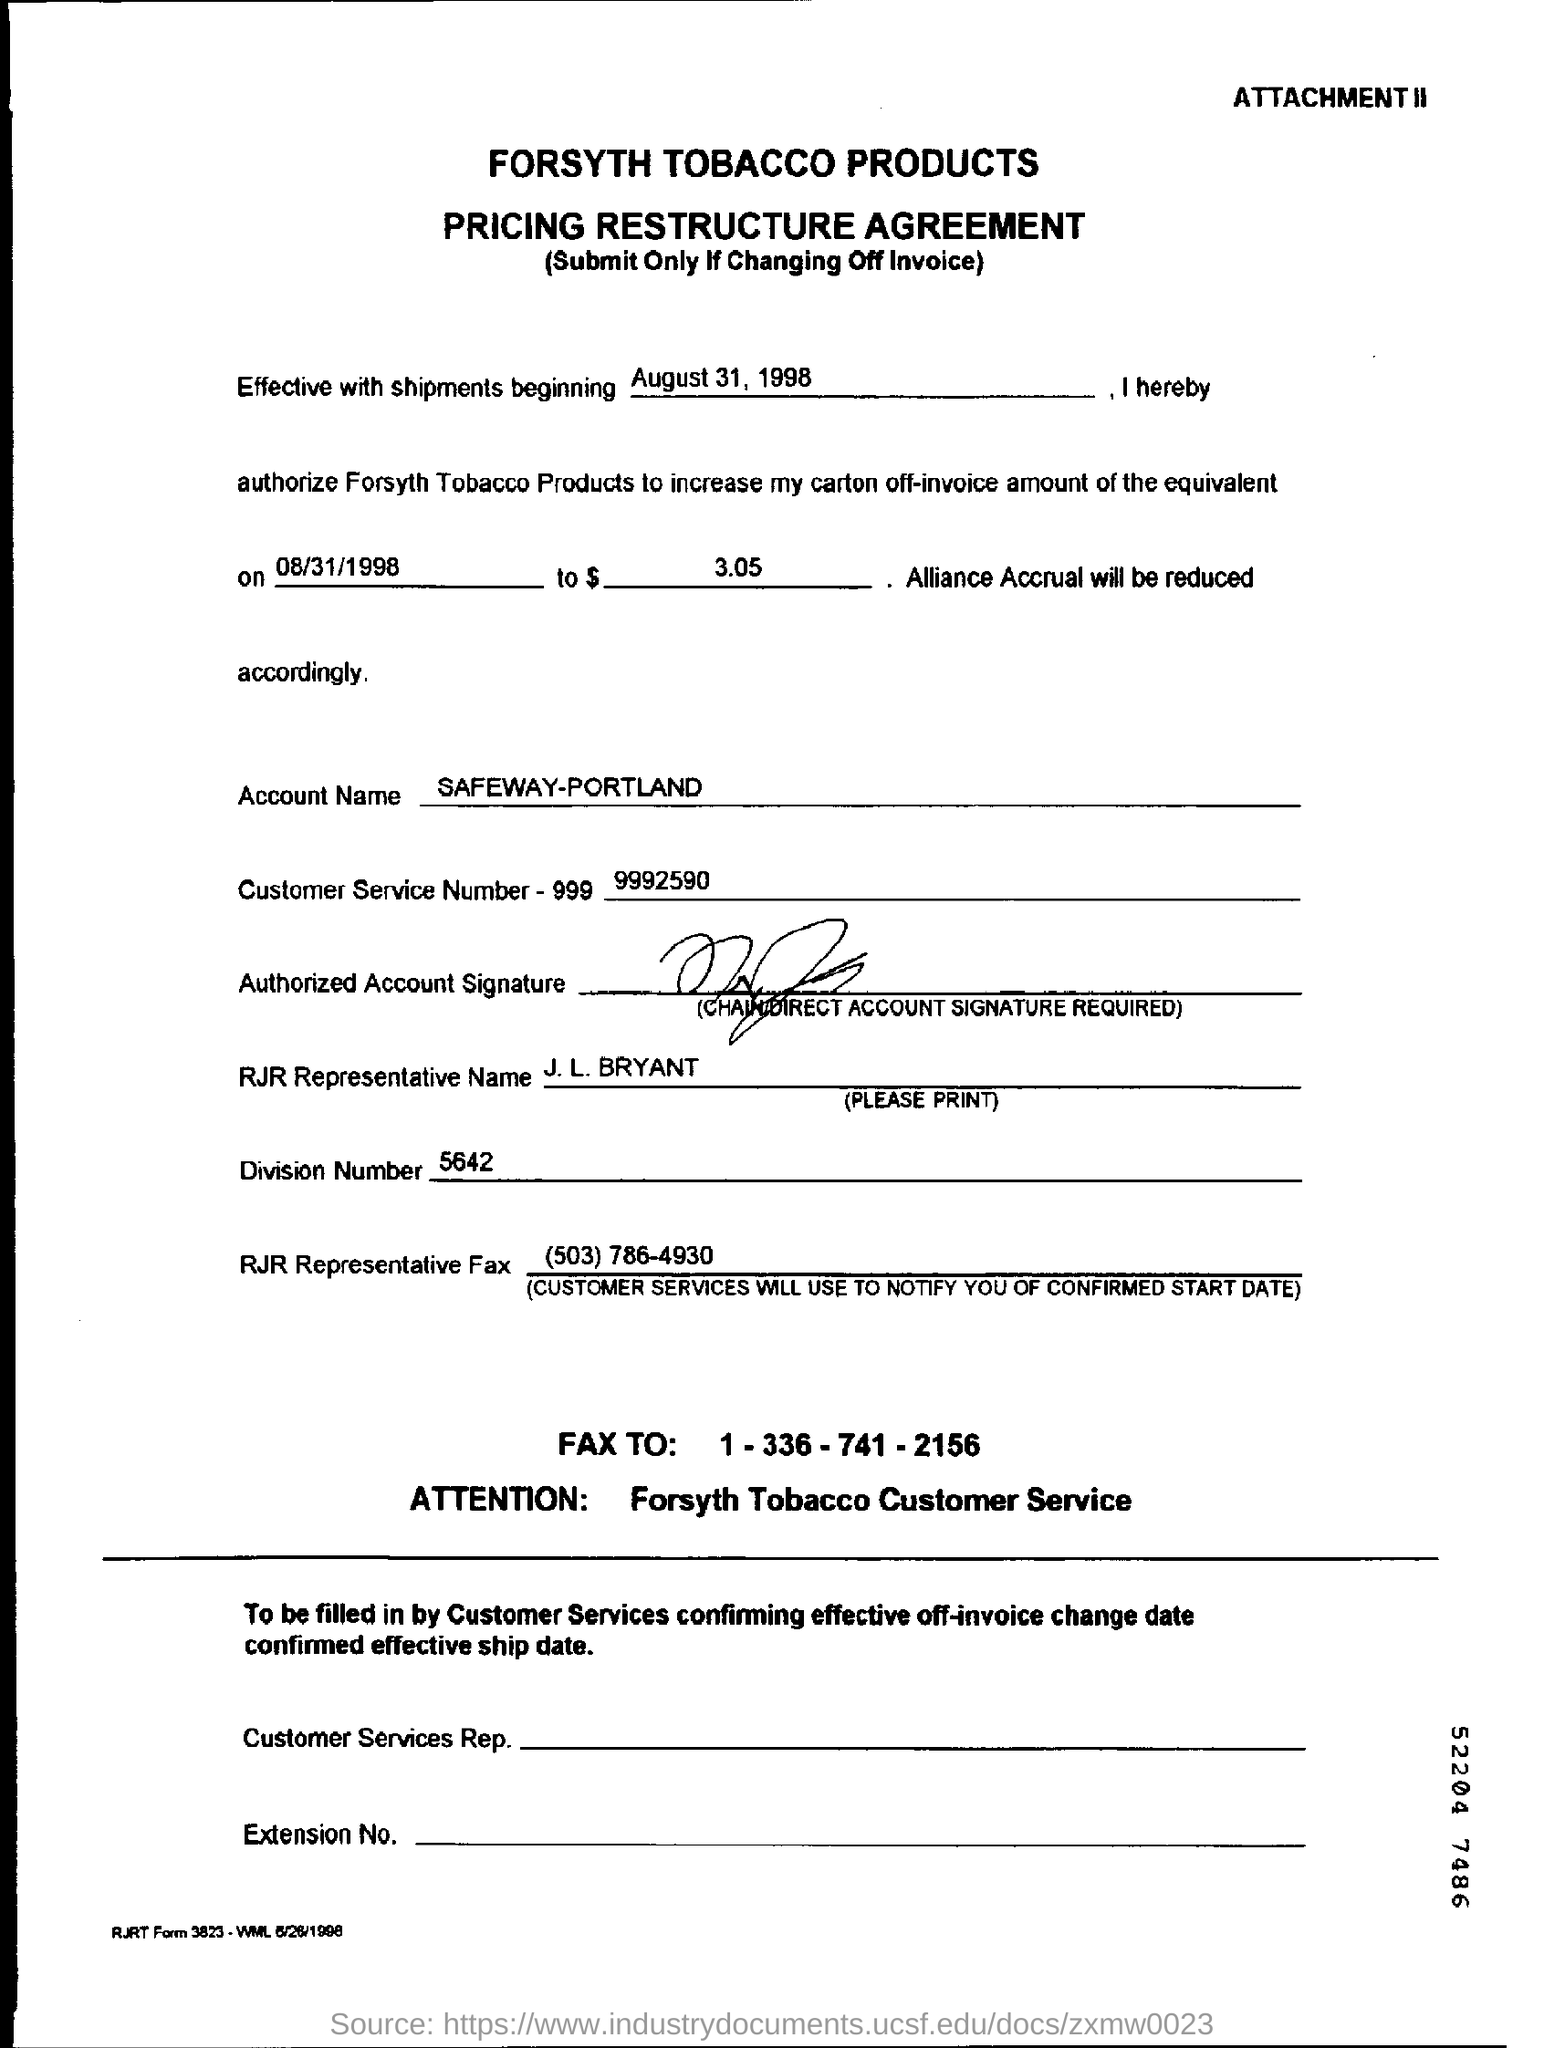What is the name of the company?
Give a very brief answer. Forsyth Tobacco Products. What is account name mentioned in this document?
Offer a very short reply. SAFEWAY-PORTLAND. What is the customer service number?
Ensure brevity in your answer.  9992590. What is name of representative who represented RJR company?
Provide a succinct answer. J. L. BRYANT. What is the division number?
Provide a succinct answer. 5642. 